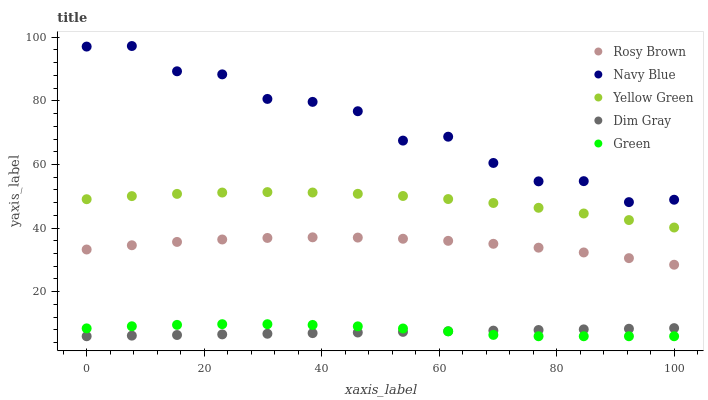Does Dim Gray have the minimum area under the curve?
Answer yes or no. Yes. Does Navy Blue have the maximum area under the curve?
Answer yes or no. Yes. Does Rosy Brown have the minimum area under the curve?
Answer yes or no. No. Does Rosy Brown have the maximum area under the curve?
Answer yes or no. No. Is Dim Gray the smoothest?
Answer yes or no. Yes. Is Navy Blue the roughest?
Answer yes or no. Yes. Is Rosy Brown the smoothest?
Answer yes or no. No. Is Rosy Brown the roughest?
Answer yes or no. No. Does Dim Gray have the lowest value?
Answer yes or no. Yes. Does Rosy Brown have the lowest value?
Answer yes or no. No. Does Navy Blue have the highest value?
Answer yes or no. Yes. Does Rosy Brown have the highest value?
Answer yes or no. No. Is Green less than Yellow Green?
Answer yes or no. Yes. Is Navy Blue greater than Dim Gray?
Answer yes or no. Yes. Does Dim Gray intersect Green?
Answer yes or no. Yes. Is Dim Gray less than Green?
Answer yes or no. No. Is Dim Gray greater than Green?
Answer yes or no. No. Does Green intersect Yellow Green?
Answer yes or no. No. 